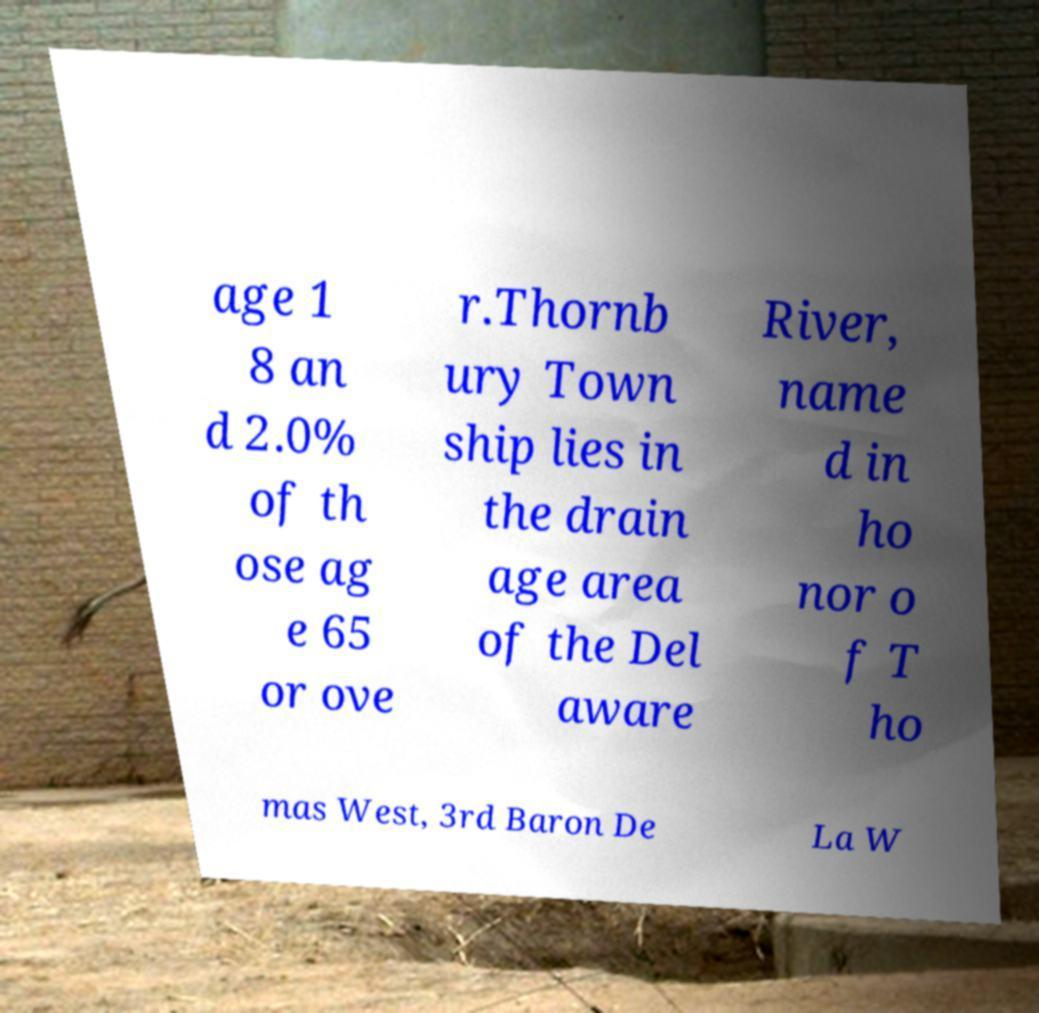Could you extract and type out the text from this image? age 1 8 an d 2.0% of th ose ag e 65 or ove r.Thornb ury Town ship lies in the drain age area of the Del aware River, name d in ho nor o f T ho mas West, 3rd Baron De La W 